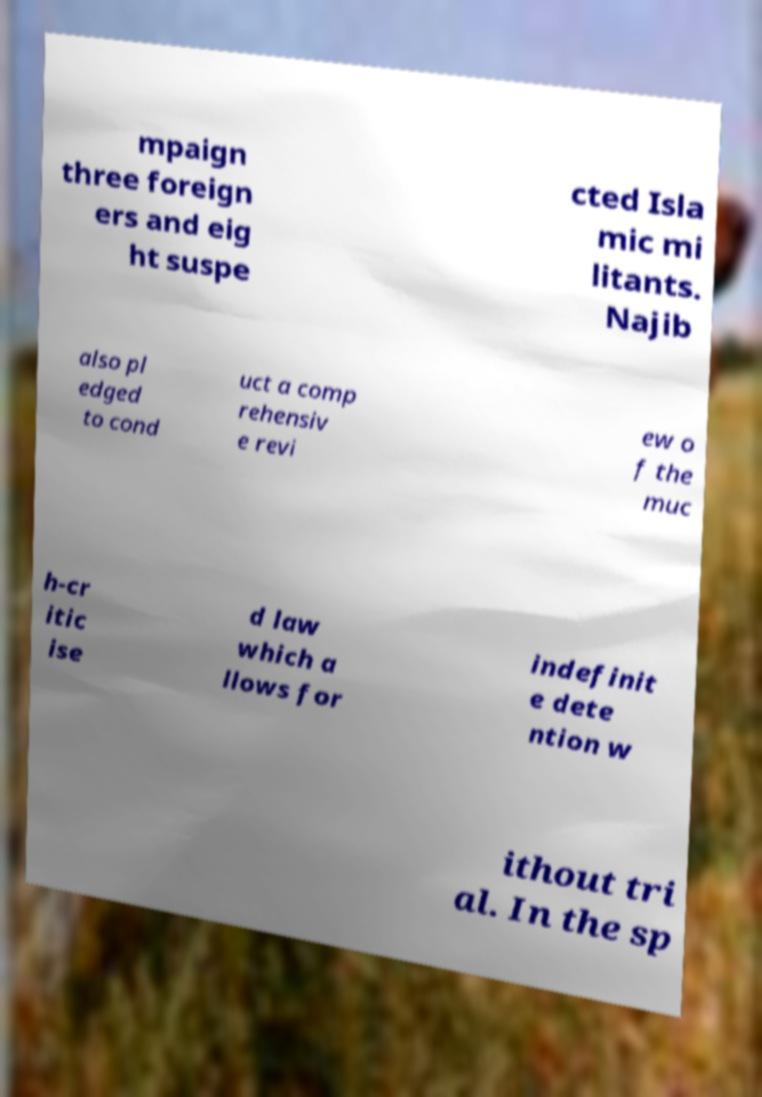For documentation purposes, I need the text within this image transcribed. Could you provide that? mpaign three foreign ers and eig ht suspe cted Isla mic mi litants. Najib also pl edged to cond uct a comp rehensiv e revi ew o f the muc h-cr itic ise d law which a llows for indefinit e dete ntion w ithout tri al. In the sp 